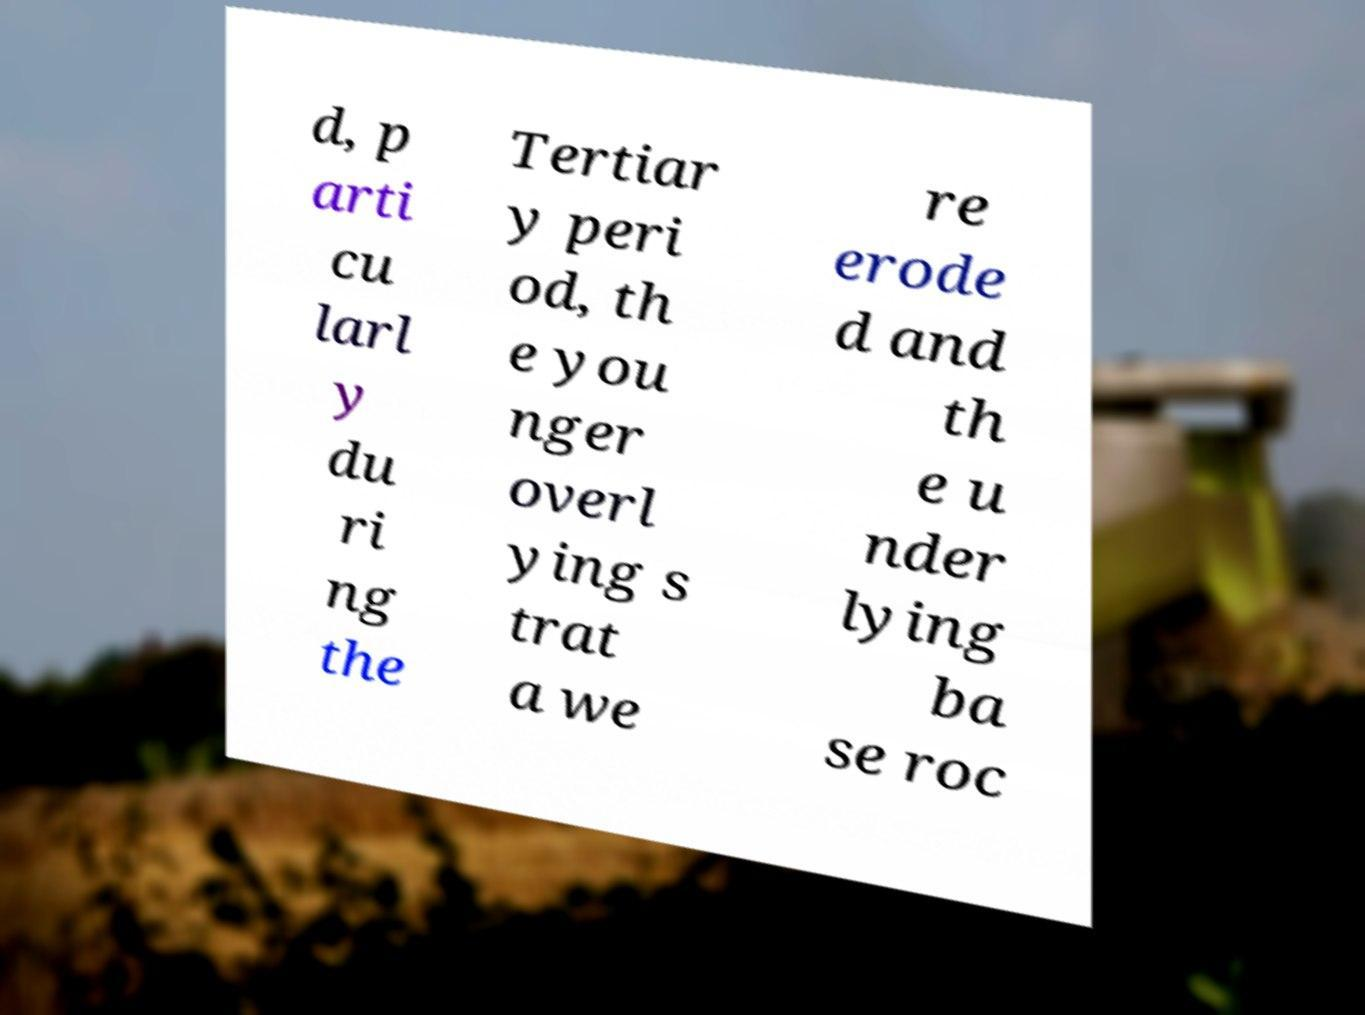Please identify and transcribe the text found in this image. d, p arti cu larl y du ri ng the Tertiar y peri od, th e you nger overl ying s trat a we re erode d and th e u nder lying ba se roc 